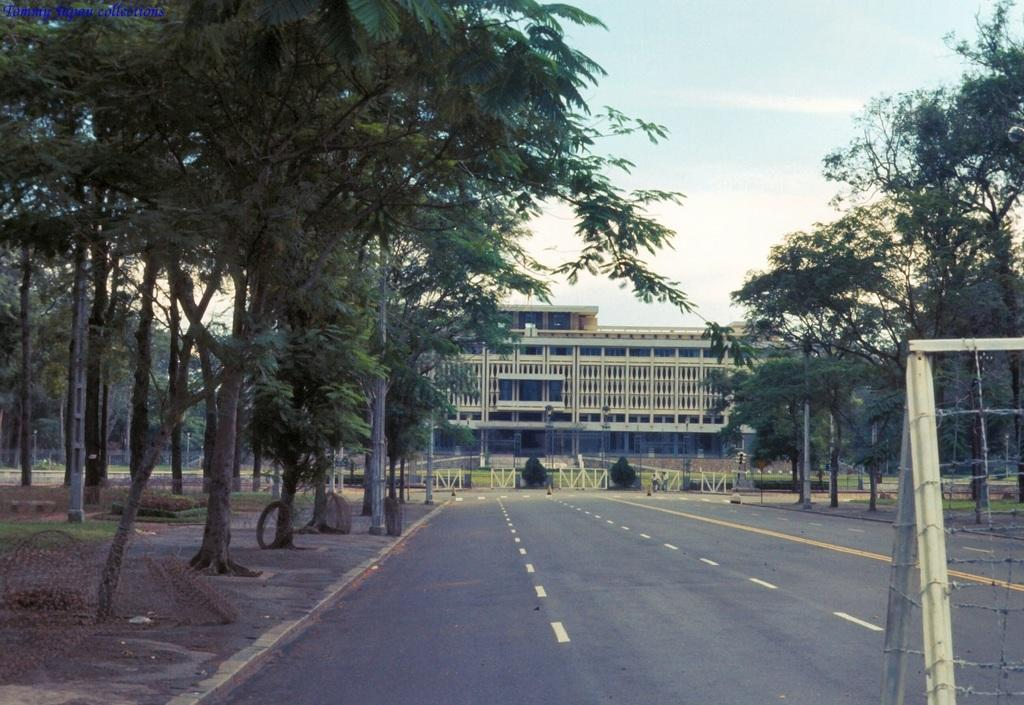What type of structure is present in the image? There is a building in the image. What type of vegetation can be seen in the image? There is grass and trees in the image. What type of barrier is present in the image? There is fencing in the image. What part of the natural environment is visible in the image? The sky is visible in the image. What type of stew is being served in the image? There is no stew present in the image. What type of society is depicted in the image? The image does not depict a society; it shows a building, grass, trees, fencing, and the sky. 